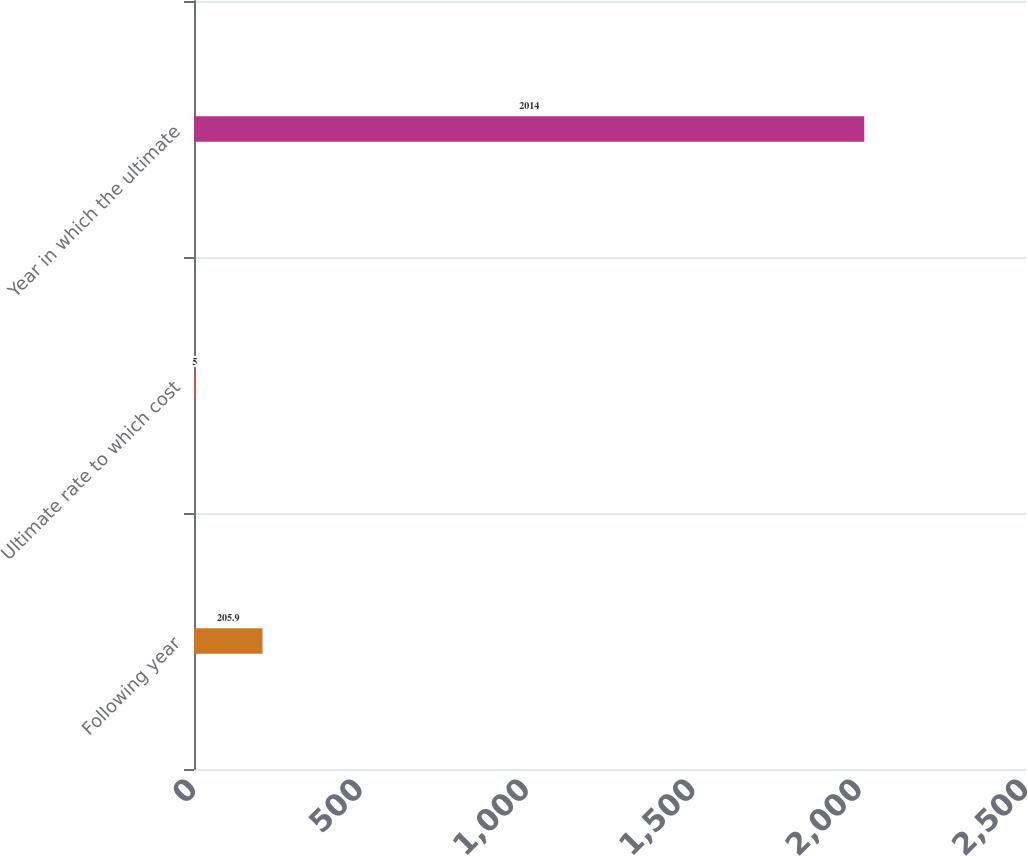Convert chart. <chart><loc_0><loc_0><loc_500><loc_500><bar_chart><fcel>Following year<fcel>Ultimate rate to which cost<fcel>Year in which the ultimate<nl><fcel>205.9<fcel>5<fcel>2014<nl></chart> 